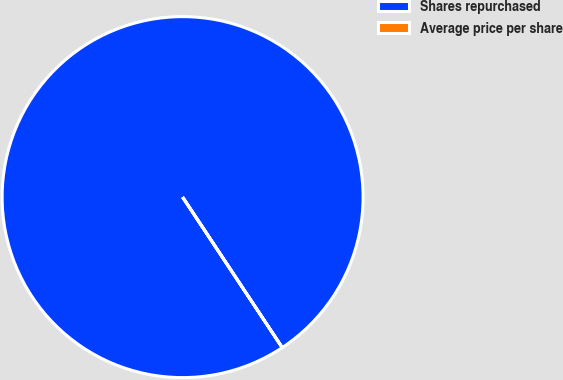Convert chart to OTSL. <chart><loc_0><loc_0><loc_500><loc_500><pie_chart><fcel>Shares repurchased<fcel>Average price per share<nl><fcel>100.0%<fcel>0.0%<nl></chart> 